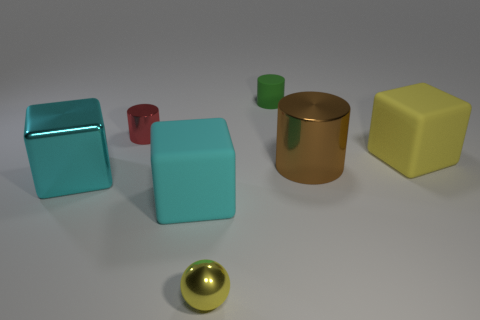Add 2 big things. How many objects exist? 9 Subtract all balls. How many objects are left? 6 Add 1 tiny red objects. How many tiny red objects exist? 2 Subtract 0 purple balls. How many objects are left? 7 Subtract all big metallic cubes. Subtract all green matte cylinders. How many objects are left? 5 Add 4 large yellow blocks. How many large yellow blocks are left? 5 